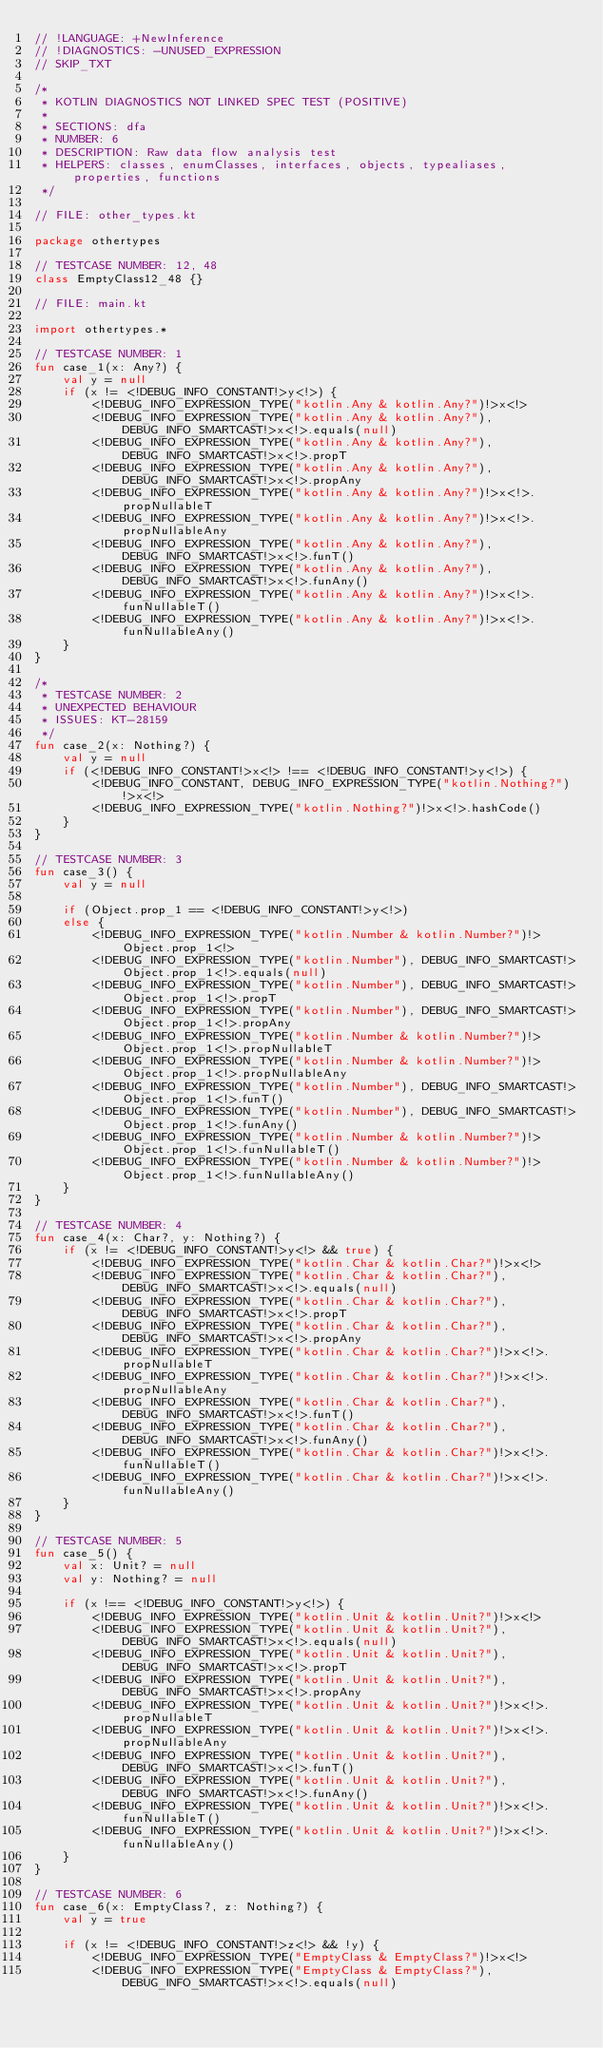Convert code to text. <code><loc_0><loc_0><loc_500><loc_500><_Kotlin_>// !LANGUAGE: +NewInference
// !DIAGNOSTICS: -UNUSED_EXPRESSION
// SKIP_TXT

/*
 * KOTLIN DIAGNOSTICS NOT LINKED SPEC TEST (POSITIVE)
 *
 * SECTIONS: dfa
 * NUMBER: 6
 * DESCRIPTION: Raw data flow analysis test
 * HELPERS: classes, enumClasses, interfaces, objects, typealiases, properties, functions
 */

// FILE: other_types.kt

package othertypes

// TESTCASE NUMBER: 12, 48
class EmptyClass12_48 {}

// FILE: main.kt

import othertypes.*

// TESTCASE NUMBER: 1
fun case_1(x: Any?) {
    val y = null
    if (x != <!DEBUG_INFO_CONSTANT!>y<!>) {
        <!DEBUG_INFO_EXPRESSION_TYPE("kotlin.Any & kotlin.Any?")!>x<!>
        <!DEBUG_INFO_EXPRESSION_TYPE("kotlin.Any & kotlin.Any?"), DEBUG_INFO_SMARTCAST!>x<!>.equals(null)
        <!DEBUG_INFO_EXPRESSION_TYPE("kotlin.Any & kotlin.Any?"), DEBUG_INFO_SMARTCAST!>x<!>.propT
        <!DEBUG_INFO_EXPRESSION_TYPE("kotlin.Any & kotlin.Any?"), DEBUG_INFO_SMARTCAST!>x<!>.propAny
        <!DEBUG_INFO_EXPRESSION_TYPE("kotlin.Any & kotlin.Any?")!>x<!>.propNullableT
        <!DEBUG_INFO_EXPRESSION_TYPE("kotlin.Any & kotlin.Any?")!>x<!>.propNullableAny
        <!DEBUG_INFO_EXPRESSION_TYPE("kotlin.Any & kotlin.Any?"), DEBUG_INFO_SMARTCAST!>x<!>.funT()
        <!DEBUG_INFO_EXPRESSION_TYPE("kotlin.Any & kotlin.Any?"), DEBUG_INFO_SMARTCAST!>x<!>.funAny()
        <!DEBUG_INFO_EXPRESSION_TYPE("kotlin.Any & kotlin.Any?")!>x<!>.funNullableT()
        <!DEBUG_INFO_EXPRESSION_TYPE("kotlin.Any & kotlin.Any?")!>x<!>.funNullableAny()
    }
}

/*
 * TESTCASE NUMBER: 2
 * UNEXPECTED BEHAVIOUR
 * ISSUES: KT-28159
 */
fun case_2(x: Nothing?) {
    val y = null
    if (<!DEBUG_INFO_CONSTANT!>x<!> !== <!DEBUG_INFO_CONSTANT!>y<!>) {
        <!DEBUG_INFO_CONSTANT, DEBUG_INFO_EXPRESSION_TYPE("kotlin.Nothing?")!>x<!>
        <!DEBUG_INFO_EXPRESSION_TYPE("kotlin.Nothing?")!>x<!>.hashCode()
    }
}

// TESTCASE NUMBER: 3
fun case_3() {
    val y = null

    if (Object.prop_1 == <!DEBUG_INFO_CONSTANT!>y<!>)
    else {
        <!DEBUG_INFO_EXPRESSION_TYPE("kotlin.Number & kotlin.Number?")!>Object.prop_1<!>
        <!DEBUG_INFO_EXPRESSION_TYPE("kotlin.Number"), DEBUG_INFO_SMARTCAST!>Object.prop_1<!>.equals(null)
        <!DEBUG_INFO_EXPRESSION_TYPE("kotlin.Number"), DEBUG_INFO_SMARTCAST!>Object.prop_1<!>.propT
        <!DEBUG_INFO_EXPRESSION_TYPE("kotlin.Number"), DEBUG_INFO_SMARTCAST!>Object.prop_1<!>.propAny
        <!DEBUG_INFO_EXPRESSION_TYPE("kotlin.Number & kotlin.Number?")!>Object.prop_1<!>.propNullableT
        <!DEBUG_INFO_EXPRESSION_TYPE("kotlin.Number & kotlin.Number?")!>Object.prop_1<!>.propNullableAny
        <!DEBUG_INFO_EXPRESSION_TYPE("kotlin.Number"), DEBUG_INFO_SMARTCAST!>Object.prop_1<!>.funT()
        <!DEBUG_INFO_EXPRESSION_TYPE("kotlin.Number"), DEBUG_INFO_SMARTCAST!>Object.prop_1<!>.funAny()
        <!DEBUG_INFO_EXPRESSION_TYPE("kotlin.Number & kotlin.Number?")!>Object.prop_1<!>.funNullableT()
        <!DEBUG_INFO_EXPRESSION_TYPE("kotlin.Number & kotlin.Number?")!>Object.prop_1<!>.funNullableAny()
    }
}

// TESTCASE NUMBER: 4
fun case_4(x: Char?, y: Nothing?) {
    if (x != <!DEBUG_INFO_CONSTANT!>y<!> && true) {
        <!DEBUG_INFO_EXPRESSION_TYPE("kotlin.Char & kotlin.Char?")!>x<!>
        <!DEBUG_INFO_EXPRESSION_TYPE("kotlin.Char & kotlin.Char?"), DEBUG_INFO_SMARTCAST!>x<!>.equals(null)
        <!DEBUG_INFO_EXPRESSION_TYPE("kotlin.Char & kotlin.Char?"), DEBUG_INFO_SMARTCAST!>x<!>.propT
        <!DEBUG_INFO_EXPRESSION_TYPE("kotlin.Char & kotlin.Char?"), DEBUG_INFO_SMARTCAST!>x<!>.propAny
        <!DEBUG_INFO_EXPRESSION_TYPE("kotlin.Char & kotlin.Char?")!>x<!>.propNullableT
        <!DEBUG_INFO_EXPRESSION_TYPE("kotlin.Char & kotlin.Char?")!>x<!>.propNullableAny
        <!DEBUG_INFO_EXPRESSION_TYPE("kotlin.Char & kotlin.Char?"), DEBUG_INFO_SMARTCAST!>x<!>.funT()
        <!DEBUG_INFO_EXPRESSION_TYPE("kotlin.Char & kotlin.Char?"), DEBUG_INFO_SMARTCAST!>x<!>.funAny()
        <!DEBUG_INFO_EXPRESSION_TYPE("kotlin.Char & kotlin.Char?")!>x<!>.funNullableT()
        <!DEBUG_INFO_EXPRESSION_TYPE("kotlin.Char & kotlin.Char?")!>x<!>.funNullableAny()
    }
}

// TESTCASE NUMBER: 5
fun case_5() {
    val x: Unit? = null
    val y: Nothing? = null

    if (x !== <!DEBUG_INFO_CONSTANT!>y<!>) {
        <!DEBUG_INFO_EXPRESSION_TYPE("kotlin.Unit & kotlin.Unit?")!>x<!>
        <!DEBUG_INFO_EXPRESSION_TYPE("kotlin.Unit & kotlin.Unit?"), DEBUG_INFO_SMARTCAST!>x<!>.equals(null)
        <!DEBUG_INFO_EXPRESSION_TYPE("kotlin.Unit & kotlin.Unit?"), DEBUG_INFO_SMARTCAST!>x<!>.propT
        <!DEBUG_INFO_EXPRESSION_TYPE("kotlin.Unit & kotlin.Unit?"), DEBUG_INFO_SMARTCAST!>x<!>.propAny
        <!DEBUG_INFO_EXPRESSION_TYPE("kotlin.Unit & kotlin.Unit?")!>x<!>.propNullableT
        <!DEBUG_INFO_EXPRESSION_TYPE("kotlin.Unit & kotlin.Unit?")!>x<!>.propNullableAny
        <!DEBUG_INFO_EXPRESSION_TYPE("kotlin.Unit & kotlin.Unit?"), DEBUG_INFO_SMARTCAST!>x<!>.funT()
        <!DEBUG_INFO_EXPRESSION_TYPE("kotlin.Unit & kotlin.Unit?"), DEBUG_INFO_SMARTCAST!>x<!>.funAny()
        <!DEBUG_INFO_EXPRESSION_TYPE("kotlin.Unit & kotlin.Unit?")!>x<!>.funNullableT()
        <!DEBUG_INFO_EXPRESSION_TYPE("kotlin.Unit & kotlin.Unit?")!>x<!>.funNullableAny()
    }
}

// TESTCASE NUMBER: 6
fun case_6(x: EmptyClass?, z: Nothing?) {
    val y = true

    if (x != <!DEBUG_INFO_CONSTANT!>z<!> && !y) {
        <!DEBUG_INFO_EXPRESSION_TYPE("EmptyClass & EmptyClass?")!>x<!>
        <!DEBUG_INFO_EXPRESSION_TYPE("EmptyClass & EmptyClass?"), DEBUG_INFO_SMARTCAST!>x<!>.equals(null)</code> 